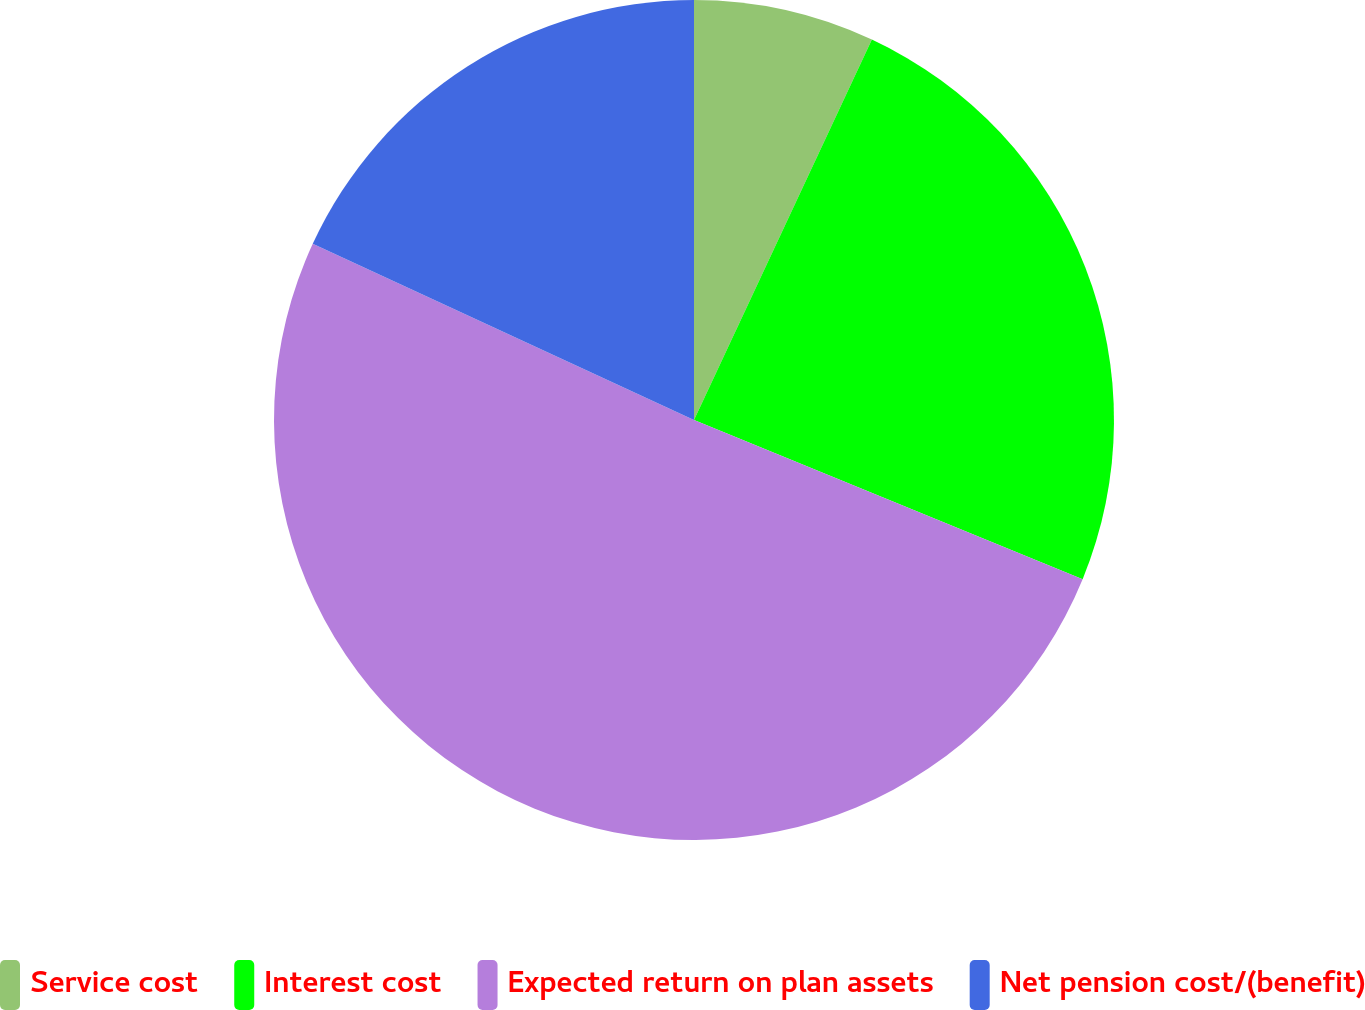<chart> <loc_0><loc_0><loc_500><loc_500><pie_chart><fcel>Service cost<fcel>Interest cost<fcel>Expected return on plan assets<fcel>Net pension cost/(benefit)<nl><fcel>6.96%<fcel>24.23%<fcel>50.7%<fcel>18.11%<nl></chart> 